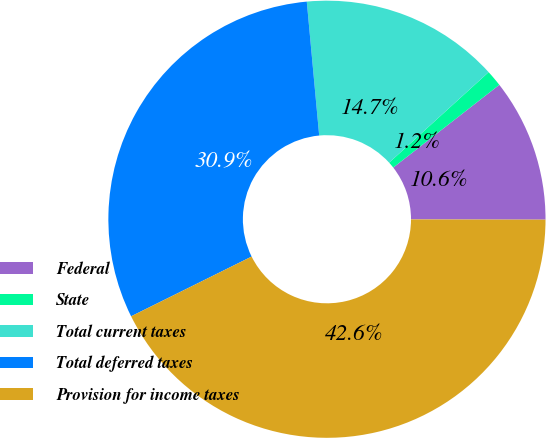Convert chart to OTSL. <chart><loc_0><loc_0><loc_500><loc_500><pie_chart><fcel>Federal<fcel>State<fcel>Total current taxes<fcel>Total deferred taxes<fcel>Provision for income taxes<nl><fcel>10.57%<fcel>1.21%<fcel>14.72%<fcel>30.85%<fcel>42.64%<nl></chart> 